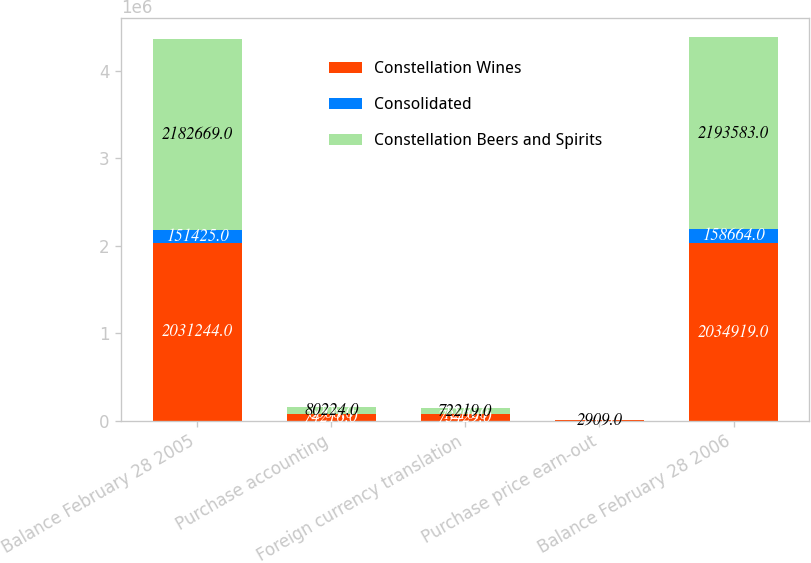Convert chart. <chart><loc_0><loc_0><loc_500><loc_500><stacked_bar_chart><ecel><fcel>Balance February 28 2005<fcel>Purchase accounting<fcel>Foreign currency translation<fcel>Purchase price earn-out<fcel>Balance February 28 2006<nl><fcel>Constellation Wines<fcel>2.03124e+06<fcel>74216<fcel>73429<fcel>2888<fcel>2.03492e+06<nl><fcel>Consolidated<fcel>151425<fcel>6008<fcel>1210<fcel>21<fcel>158664<nl><fcel>Constellation Beers and Spirits<fcel>2.18267e+06<fcel>80224<fcel>72219<fcel>2909<fcel>2.19358e+06<nl></chart> 